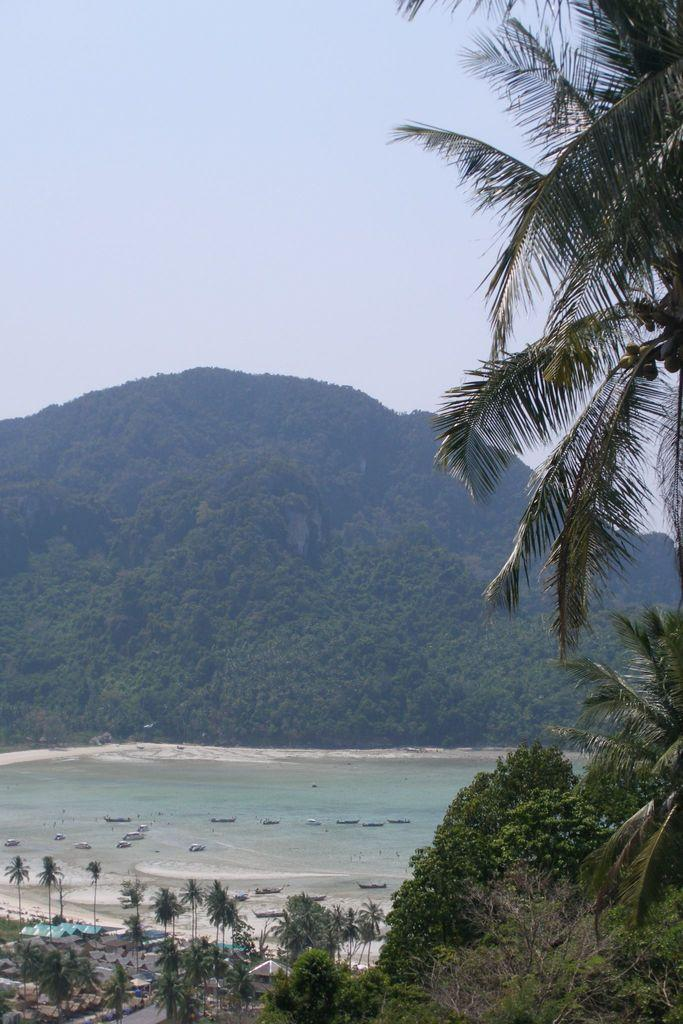What type of vegetation can be seen in the image? There are trees in the image. What natural element is visible besides the trees? There is water visible in the image. What geographical feature can be seen in the background of the image? There is a hill in the background of the image. What is visible at the top of the image? The sky is visible at the top of the image. How does the steam affect the trees in the image? There is no steam present in the image, so it does not affect the trees. What type of pain is depicted in the image? There is no depiction of pain in the image; it features trees, water, a hill, and the sky. 